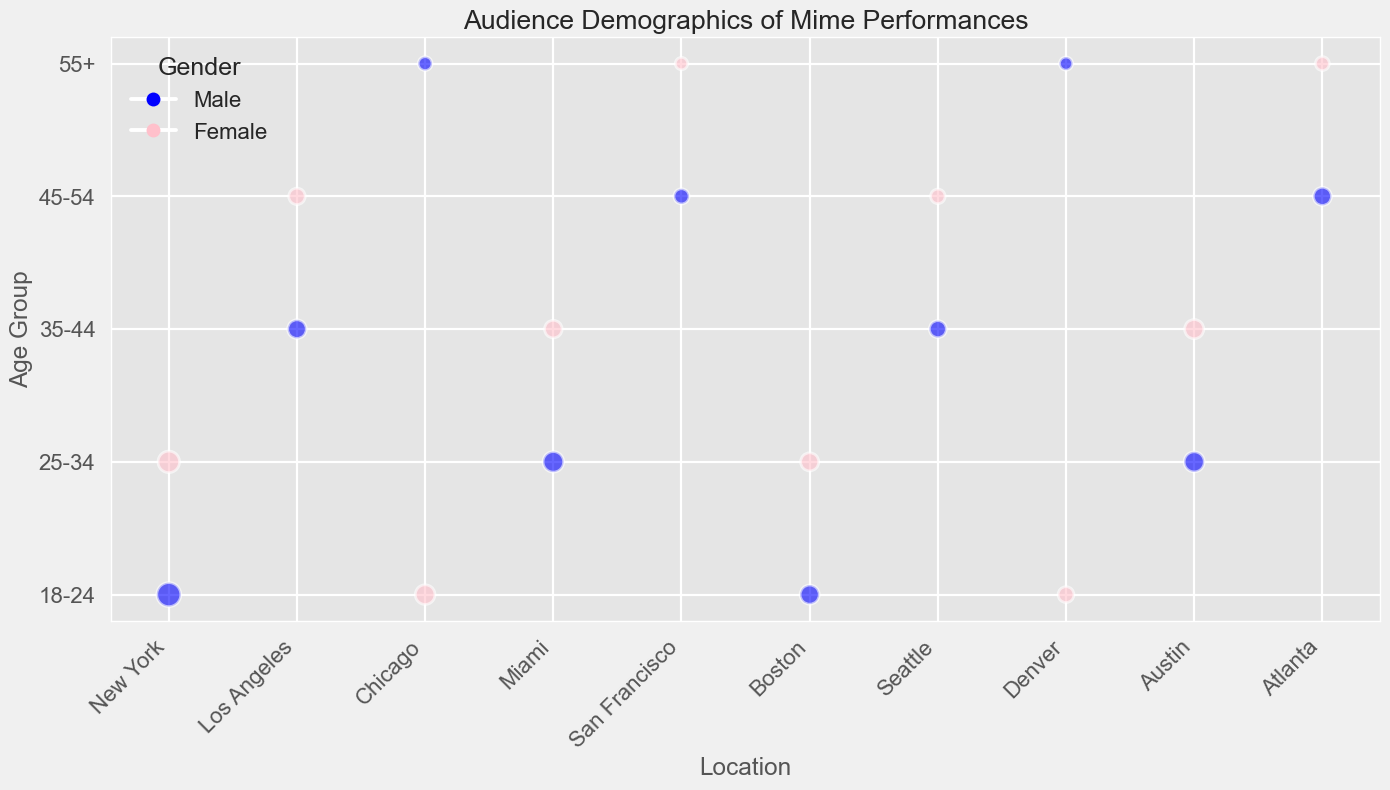What is the gender distribution of the audience in New York? Look at the colors of the bubbles in New York. There are two bubbles: one blue (male) with an audience of 150, and one pink (female) with an audience of 120.
Answer: 150 males and 120 females Which age group has the largest audience in Chicago? Observe the bubble sizes in Chicago, comparing each age group. The largest bubble corresponds to the 18-24 age group.
Answer: 18-24 age group How many total audience members are there in Denver? Sum the audience counts for both males and females in Denver. The 18-24 Female group has 65, and the 55+ Male group has 45. So, 65 + 45 = 110.
Answer: 110 Which location has the highest number of male audience members aged 25-34? Check the bubble sizes for males aged 25-34 across locations. The largest bubble is in Austin with an audience count of 105.
Answer: Austin Are there more male or female audience members aged 35-44 in Miami? Compare the bubble sizes for males and females aged 35-44 in Miami. The Female bubble has a count of 80, while the Male bubble has none.
Answer: Female Is there any location where the female audience count for the 45-54 age group is higher than its male counterpart? Check locations with bubbles for both genders aged 45-54. Compare their sizes. In Seattle, the Female (55) is higher than the Male (none).
Answer: Seattle Which location has the smallest audience count for the 55+ Female group? Compare the pink bubbles for the 55+ Female group across locations. The smallest bubble is in San Francisco with a count of 40.
Answer: San Francisco What is the average audience count for males in Los Angeles? In Los Angeles, look at the bubble for 35-44 Male (90) and there is no male audience for other age groups. Since it is the only data point, the average is the same, 90.
Answer: 90 